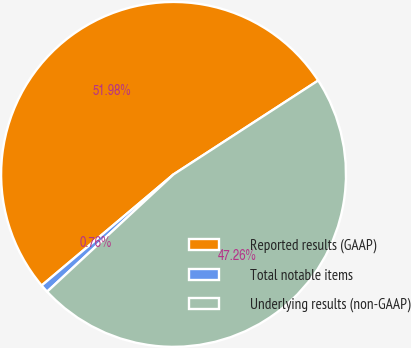Convert chart. <chart><loc_0><loc_0><loc_500><loc_500><pie_chart><fcel>Reported results (GAAP)<fcel>Total notable items<fcel>Underlying results (non-GAAP)<nl><fcel>51.98%<fcel>0.76%<fcel>47.26%<nl></chart> 